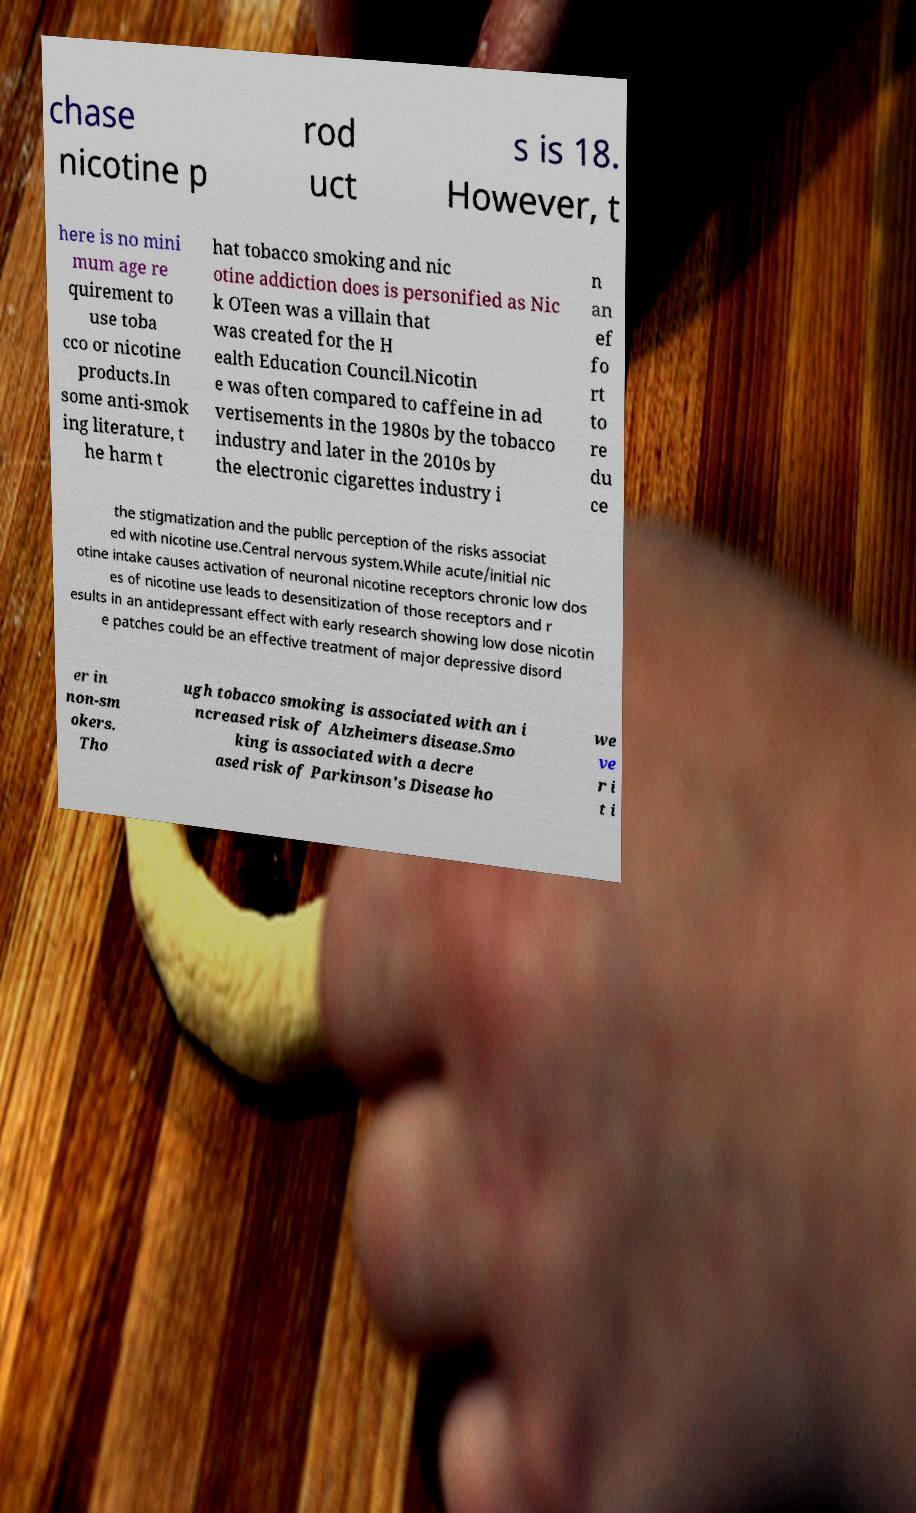Could you extract and type out the text from this image? chase nicotine p rod uct s is 18. However, t here is no mini mum age re quirement to use toba cco or nicotine products.In some anti-smok ing literature, t he harm t hat tobacco smoking and nic otine addiction does is personified as Nic k OTeen was a villain that was created for the H ealth Education Council.Nicotin e was often compared to caffeine in ad vertisements in the 1980s by the tobacco industry and later in the 2010s by the electronic cigarettes industry i n an ef fo rt to re du ce the stigmatization and the public perception of the risks associat ed with nicotine use.Central nervous system.While acute/initial nic otine intake causes activation of neuronal nicotine receptors chronic low dos es of nicotine use leads to desensitization of those receptors and r esults in an antidepressant effect with early research showing low dose nicotin e patches could be an effective treatment of major depressive disord er in non-sm okers. Tho ugh tobacco smoking is associated with an i ncreased risk of Alzheimers disease.Smo king is associated with a decre ased risk of Parkinson's Disease ho we ve r i t i 